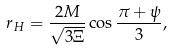<formula> <loc_0><loc_0><loc_500><loc_500>r _ { H } = \frac { 2 M } { \sqrt { 3 \Xi } } \cos \frac { \pi + \psi } { 3 } ,</formula> 